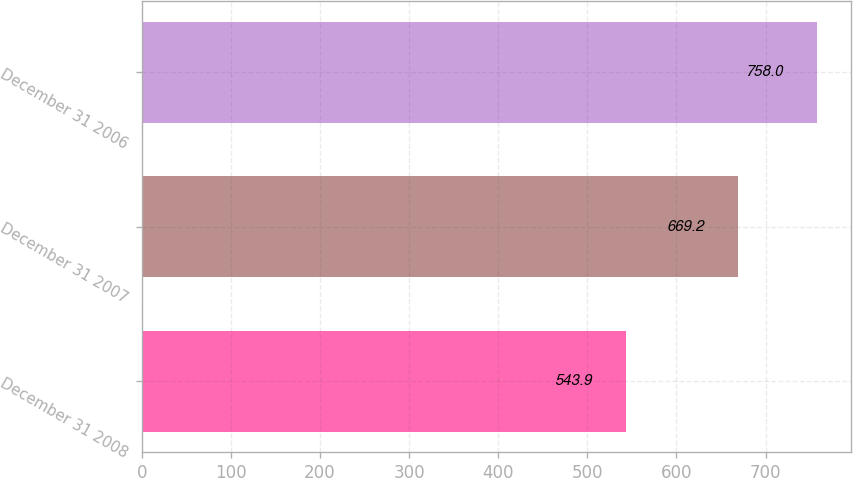Convert chart to OTSL. <chart><loc_0><loc_0><loc_500><loc_500><bar_chart><fcel>December 31 2008<fcel>December 31 2007<fcel>December 31 2006<nl><fcel>543.9<fcel>669.2<fcel>758<nl></chart> 